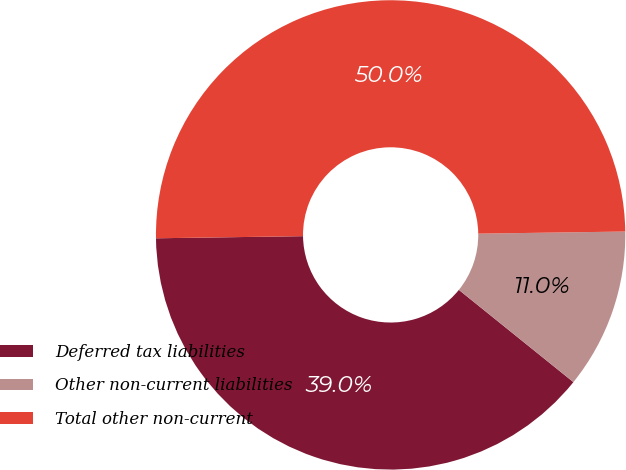<chart> <loc_0><loc_0><loc_500><loc_500><pie_chart><fcel>Deferred tax liabilities<fcel>Other non-current liabilities<fcel>Total other non-current<nl><fcel>38.98%<fcel>11.02%<fcel>50.0%<nl></chart> 